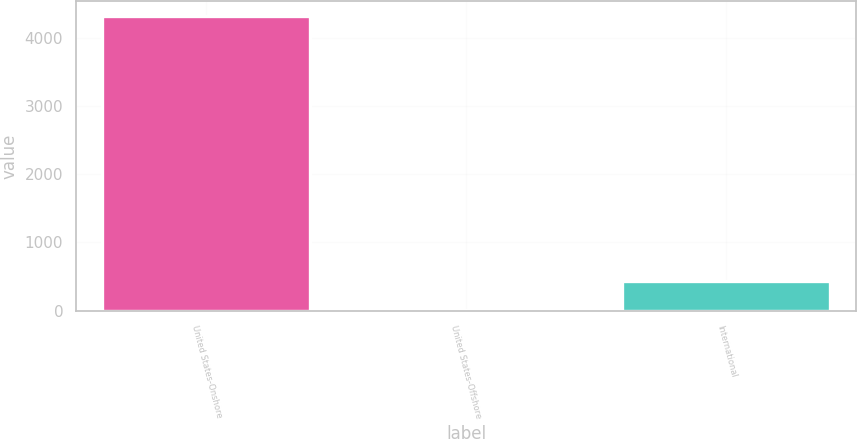Convert chart to OTSL. <chart><loc_0><loc_0><loc_500><loc_500><bar_chart><fcel>United States-Onshore<fcel>United States-Offshore<fcel>International<nl><fcel>4324<fcel>9<fcel>440.5<nl></chart> 